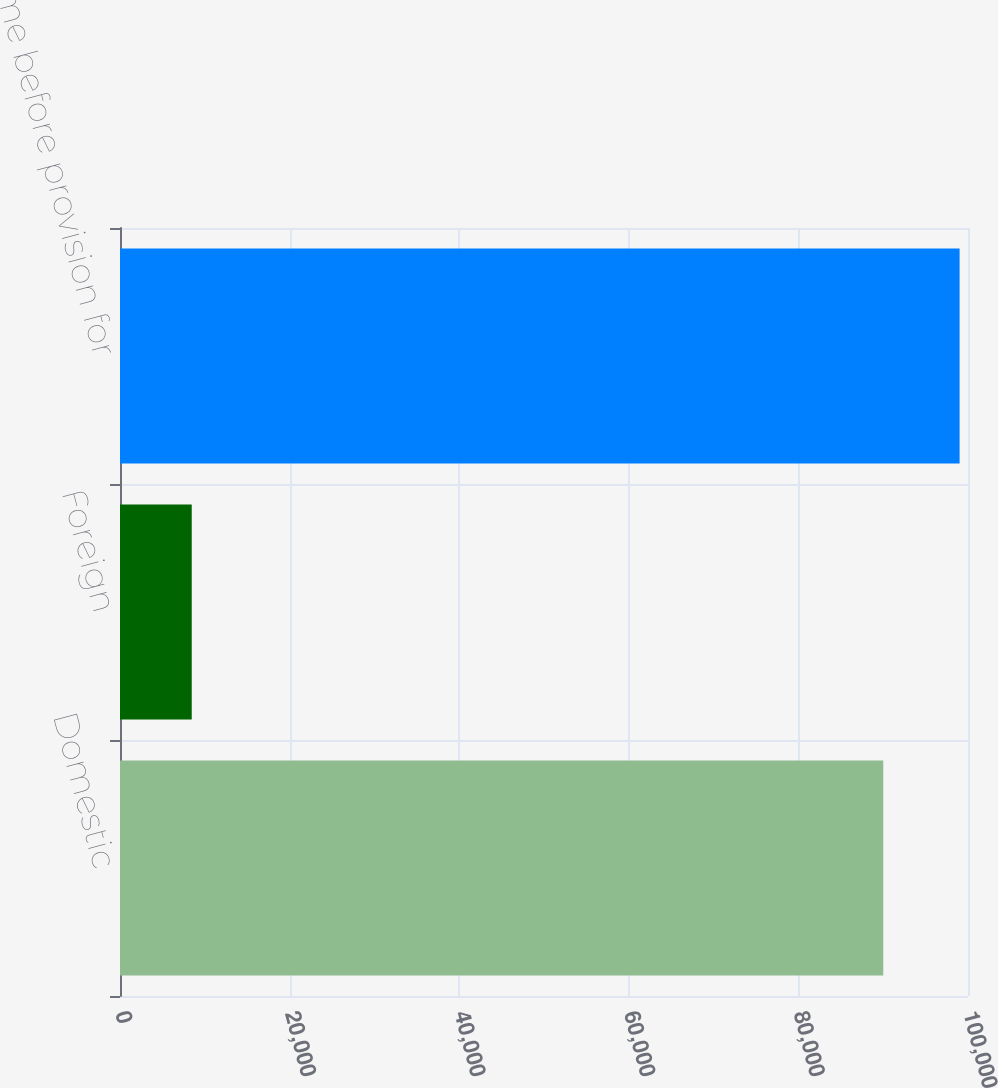Convert chart. <chart><loc_0><loc_0><loc_500><loc_500><bar_chart><fcel>Domestic<fcel>Foreign<fcel>Income before provision for<nl><fcel>90009<fcel>8460<fcel>99009.9<nl></chart> 